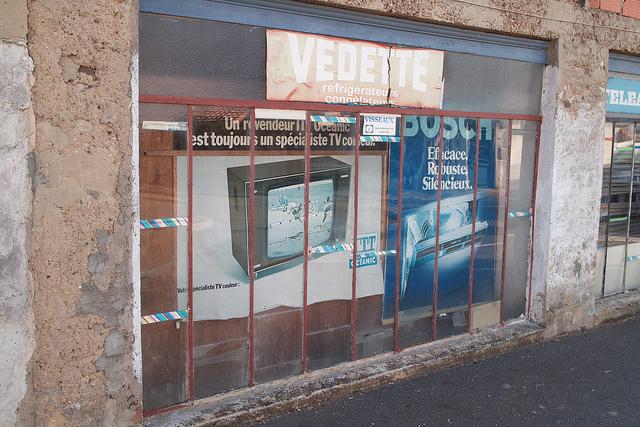Is the building new?
Concise answer only. No. Is this a European city?
Be succinct. Yes. What language are these signs in?
Give a very brief answer. Spanish. Who is standing in the picture?
Answer briefly. No one. 